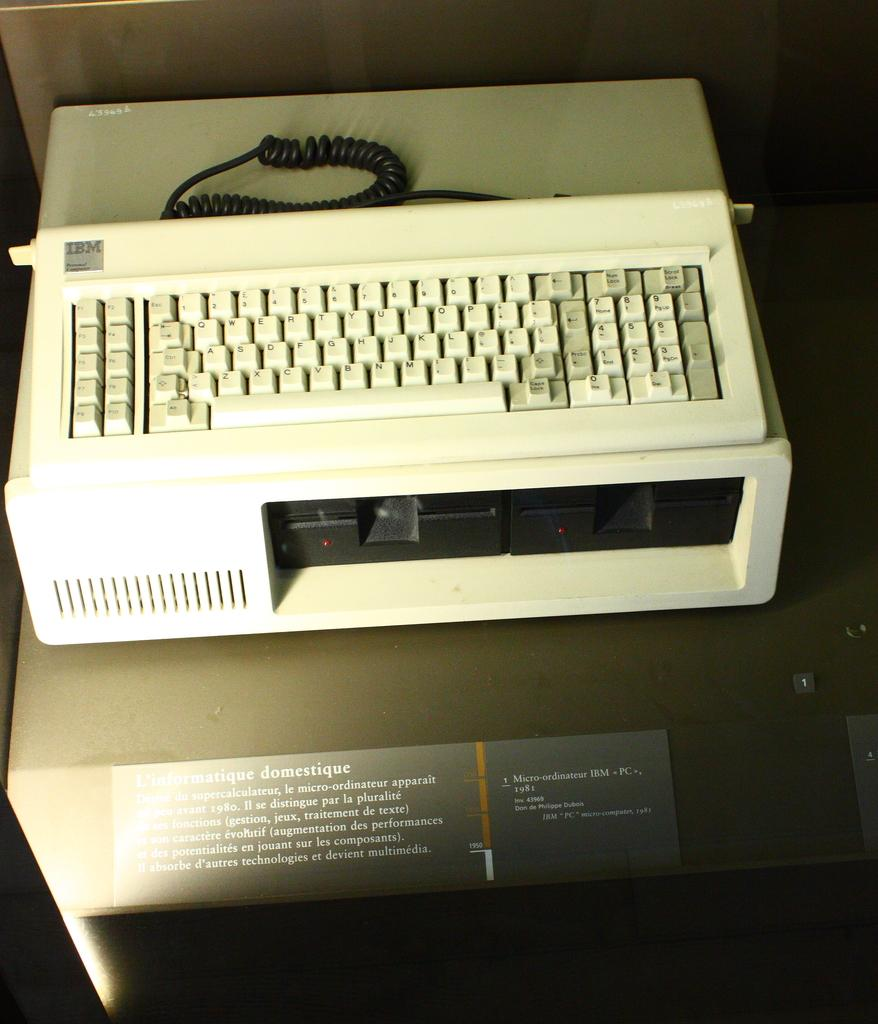What is the main object in the image? There is a keyboard in the image. Can you describe any other elements in the image? There is a wire in the image. Is there any text visible in the image? Yes, there is some text written in the foreground of the image. What type of smoke can be seen coming from the keyboard in the image? There is no smoke present in the image; it features a keyboard and a wire. 